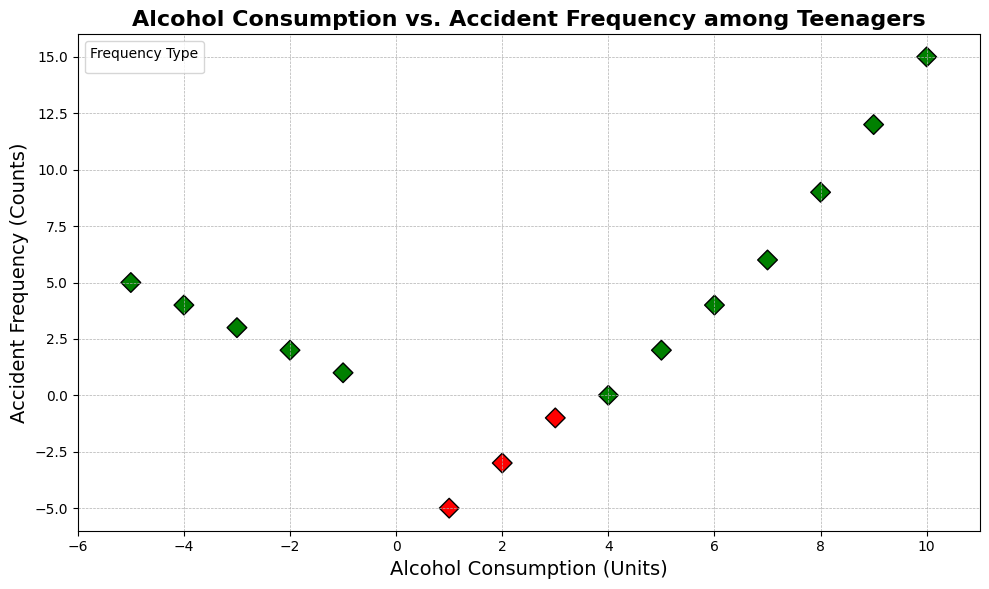What is the highest point's frequency of accidents? The highest point on the scatter plot in terms of accident frequency is at the top-most position. The y-axis value at this point is 15.
Answer: 15 Which data points have negative accident frequencies? Data points with negative accident frequencies are those plotted below the x-axis. The points are (1, -5), (2, -3), and (3, -1).
Answer: (1, -5), (2, -3), (3, -1) What is the sum of accident frequencies for alcohol consumption levels -1 and -2? The accident frequencies for alcohol consumption levels -1 and -2 are 1 and 2, respectively. Summing them up gives 1 + 2 = 3.
Answer: 3 Which accident frequency corresponds to an alcohol consumption level of 8 units? For an alcohol consumption level of 8 units, the accident frequency can be found on the y-axis at this x-axis point, which is 9.
Answer: 9 Is there a correlation between alcohol consumption and accident frequency? By observing the trend of the scatter points, as alcohol consumption increases, the accident frequency also generally increases. This suggests a positive correlation.
Answer: Yes Between alcohol consumption levels of 3 and 6, how many accident frequencies are non-negative? For alcohol consumption levels of 3, 4, 5, and 6, the accident frequencies are -1, 0, 2, and 4, respectively. Non-negative values are 0, 2, and 4. Therefore, there are 3 such points.
Answer: 3 What color represents positive accident frequencies in the plot? Positive accident frequencies are indicated by green color in the scatter plot.
Answer: Green 